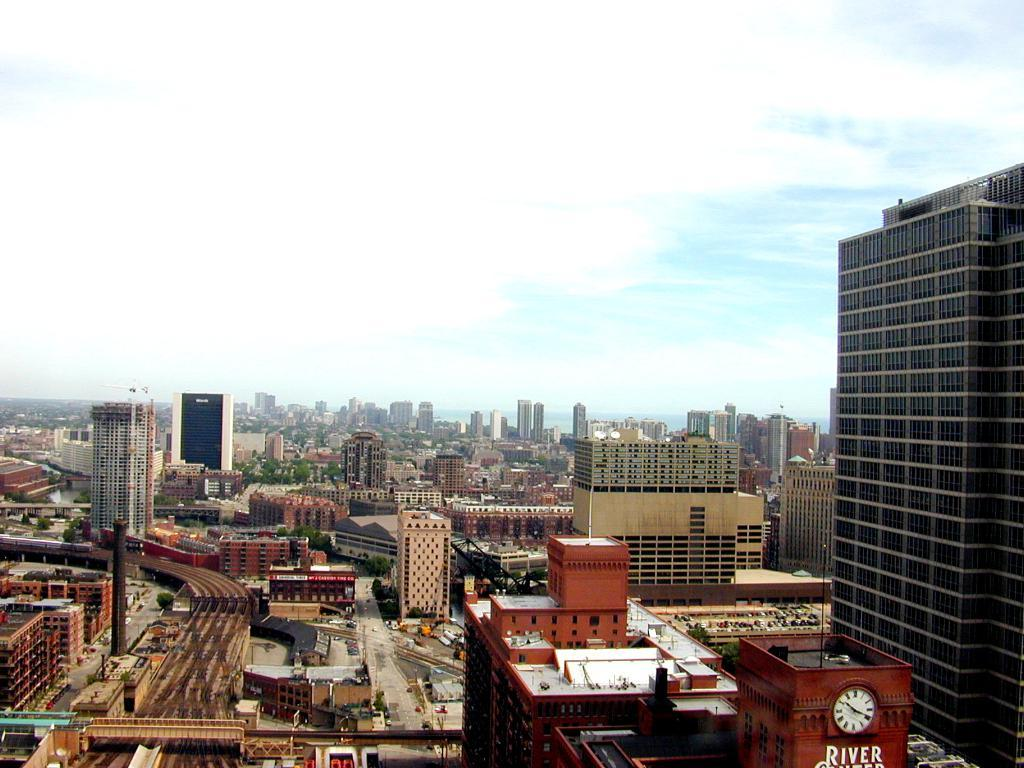What type of structures can be seen in the image? There are many buildings and skyscrapers in the image. What can be seen in the sky at the top of the image? There are clouds in the sky at the top of the image. What type of transportation infrastructure is visible in the image? There are roads visible in the image. What type of station is visible in the image? There is no station present in the image; it primarily features buildings, skyscrapers, clouds, and roads. 